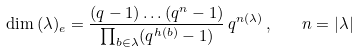<formula> <loc_0><loc_0><loc_500><loc_500>\dim \, ( \lambda ) _ { e } = \frac { ( q - 1 ) \dots ( q ^ { n } - 1 ) } { \prod _ { b \in \lambda } ( q ^ { h ( b ) } - 1 ) } \, q ^ { n ( \lambda ) } \, , \quad n = | \lambda |</formula> 